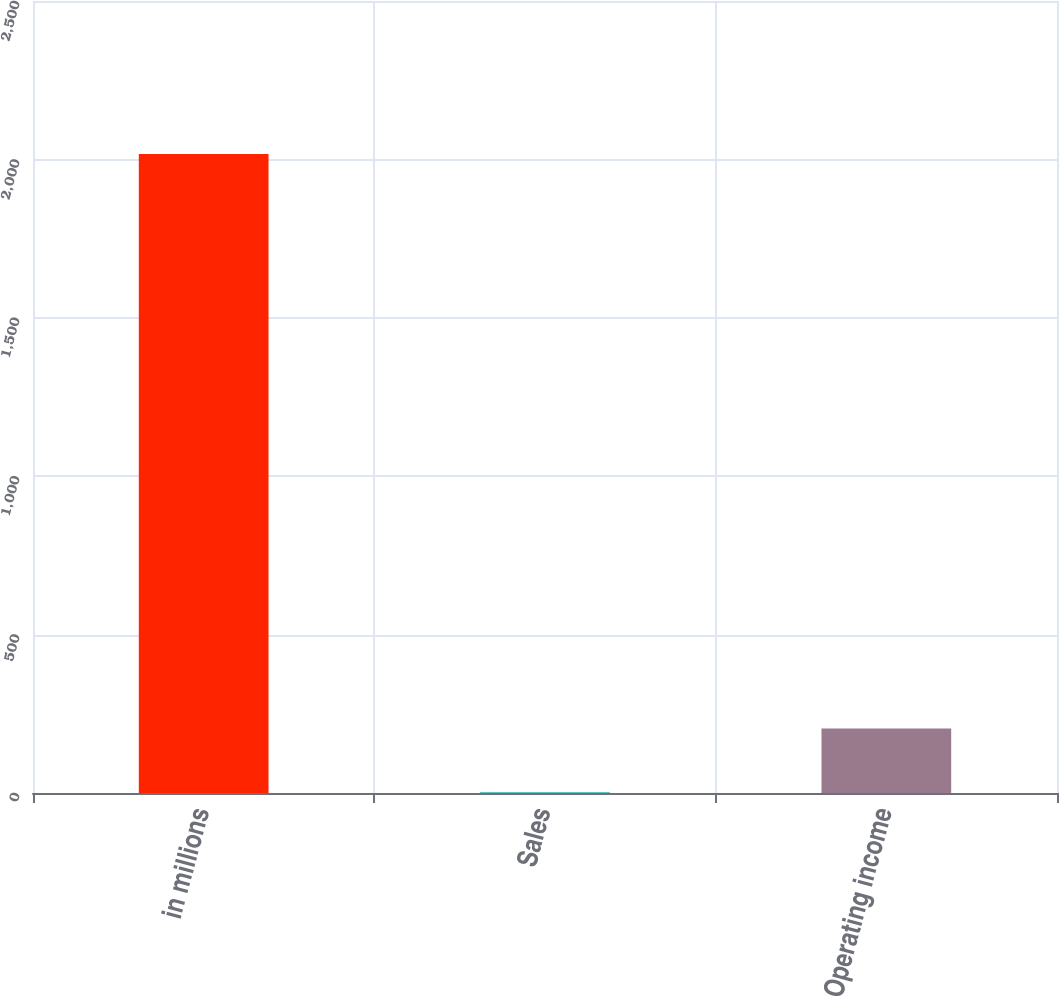<chart> <loc_0><loc_0><loc_500><loc_500><bar_chart><fcel>in millions<fcel>Sales<fcel>Operating income<nl><fcel>2017<fcel>2<fcel>203.5<nl></chart> 